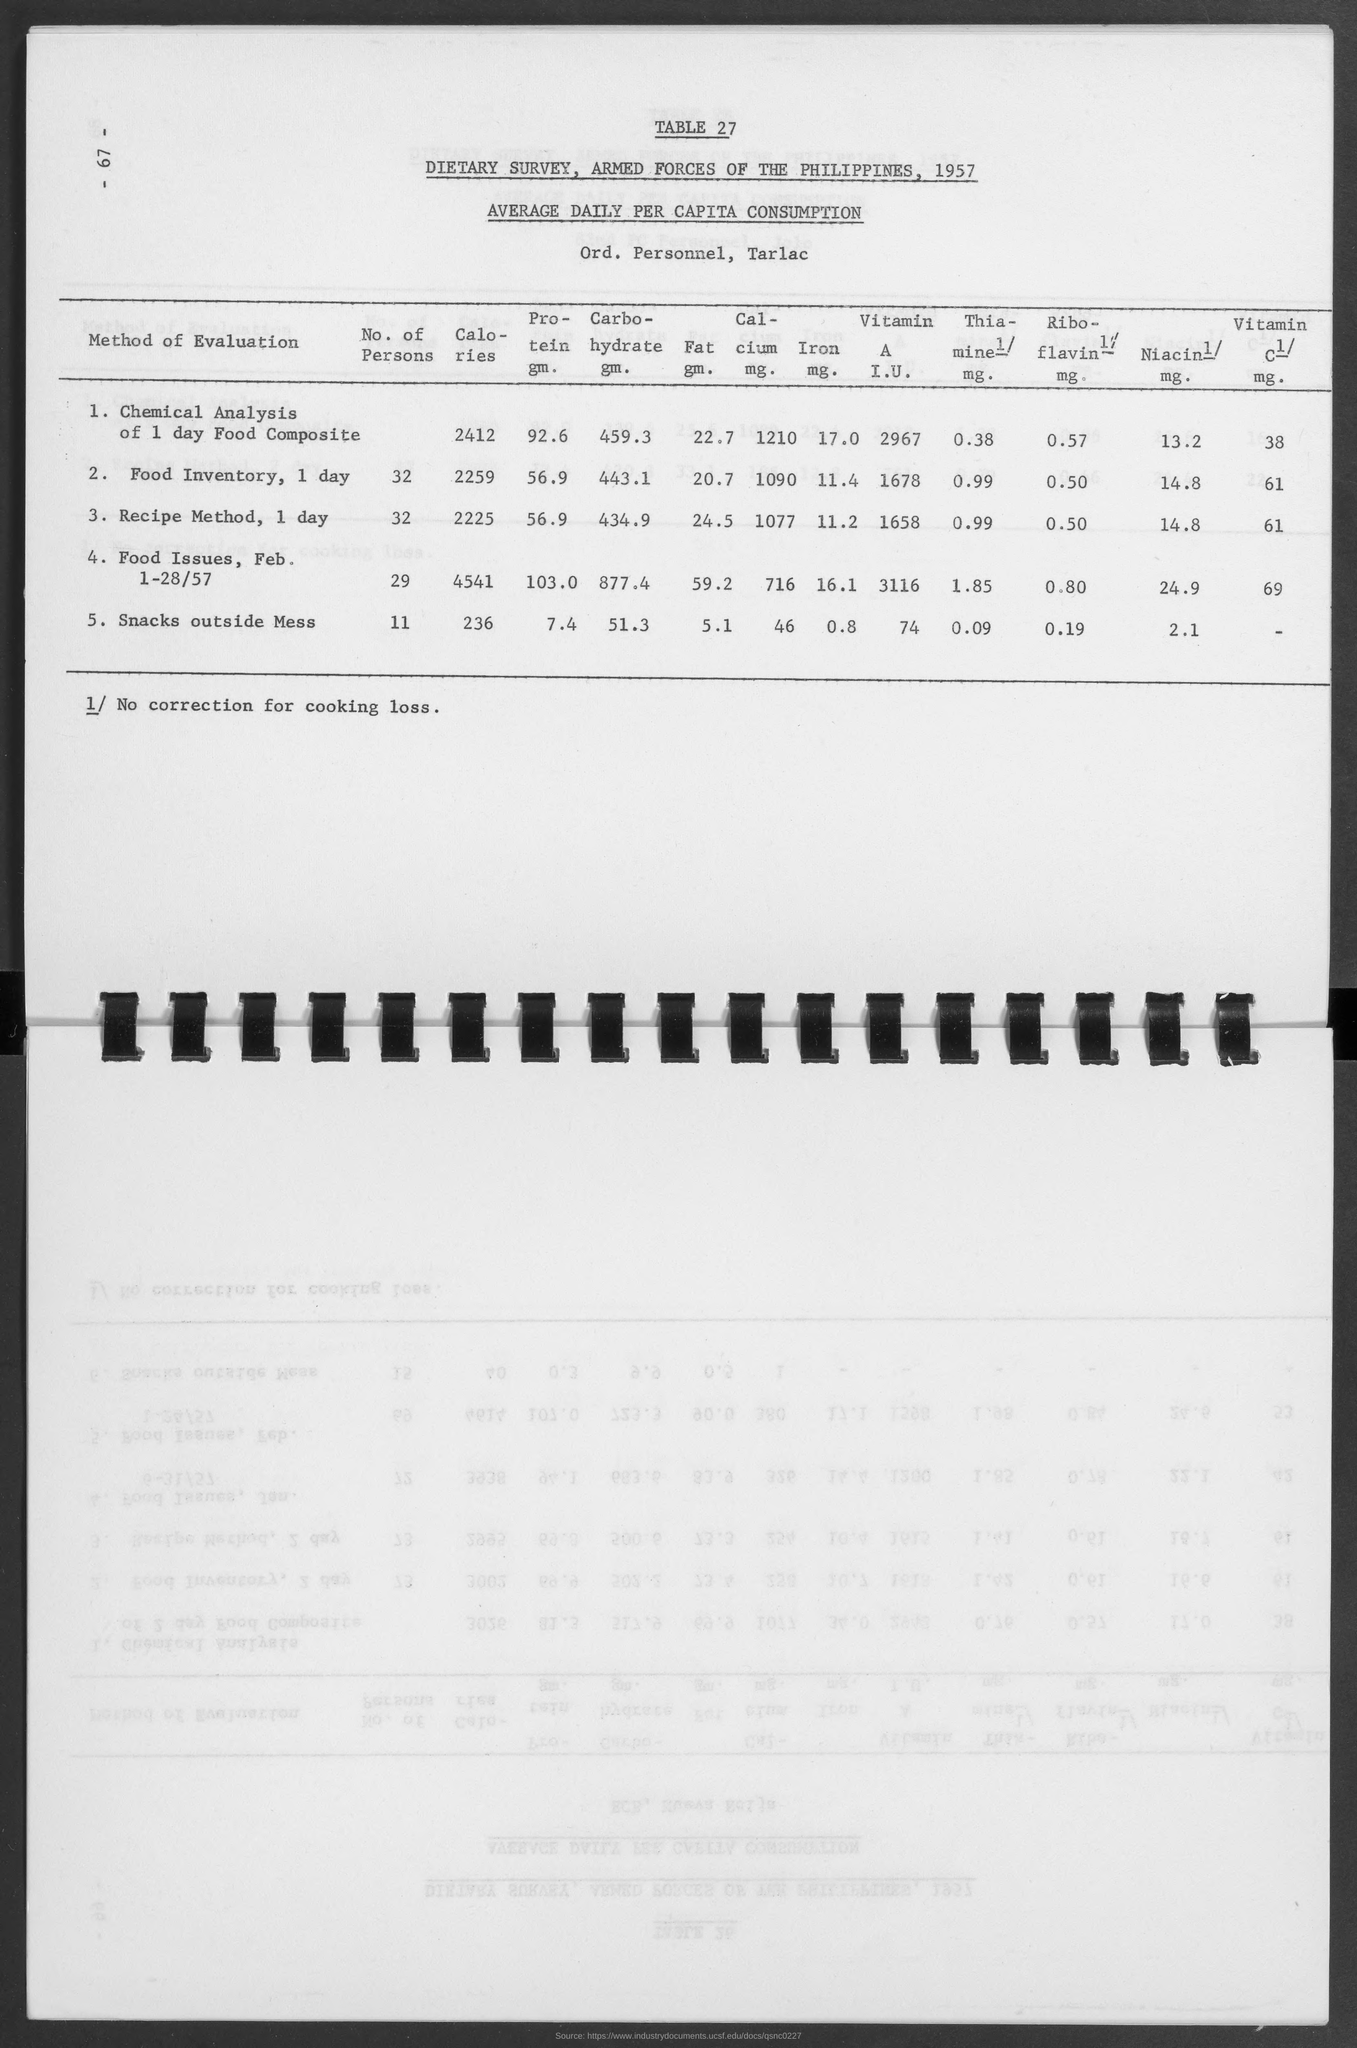What is the year mentioned in the topic?
Keep it short and to the point. 1957. What is the  value given for "recipe method, 1 day" under the column "fat gm."
Ensure brevity in your answer.  24.5. Which country is mentioned in the title?
Offer a terse response. Philippines. What is the value of "riboflavin 1/mg." for "snacks outside mess"?
Provide a short and direct response. 0.19. 